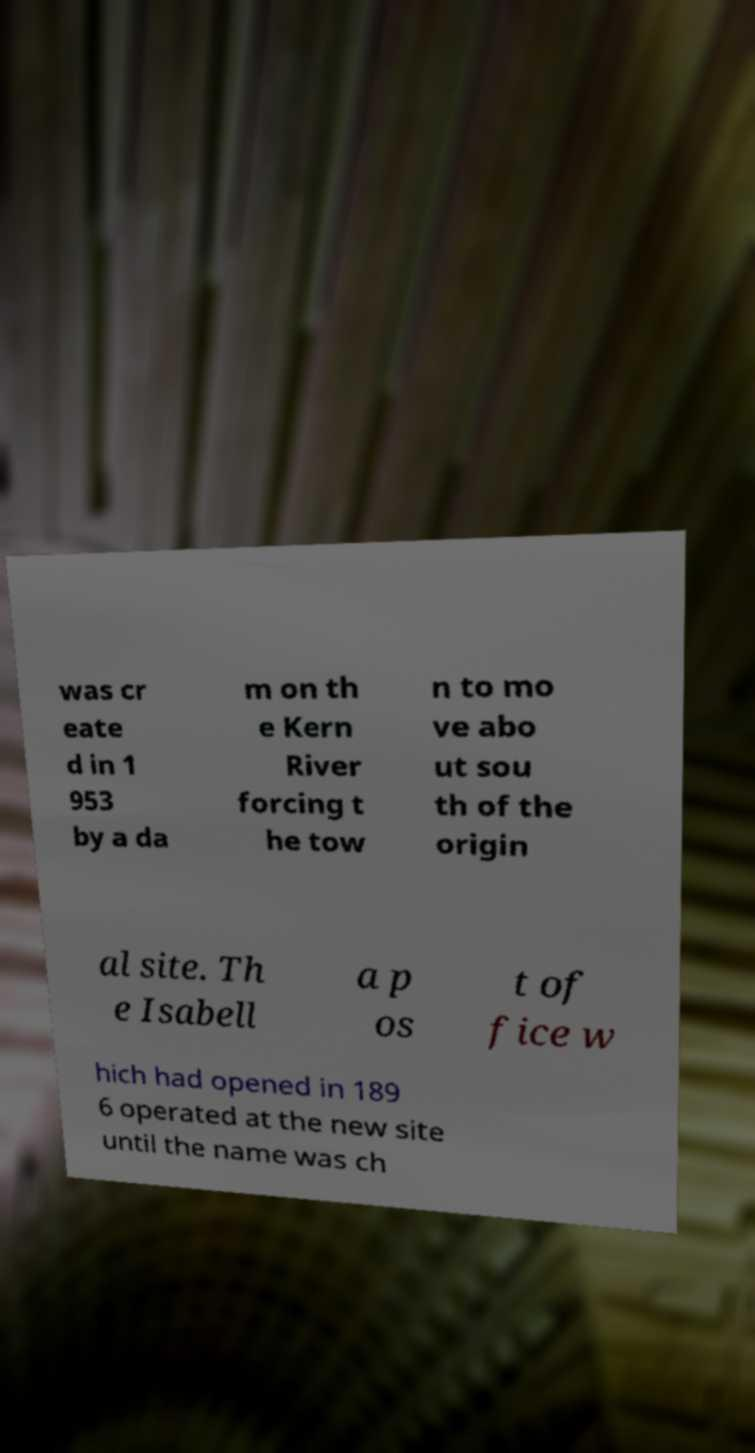For documentation purposes, I need the text within this image transcribed. Could you provide that? was cr eate d in 1 953 by a da m on th e Kern River forcing t he tow n to mo ve abo ut sou th of the origin al site. Th e Isabell a p os t of fice w hich had opened in 189 6 operated at the new site until the name was ch 